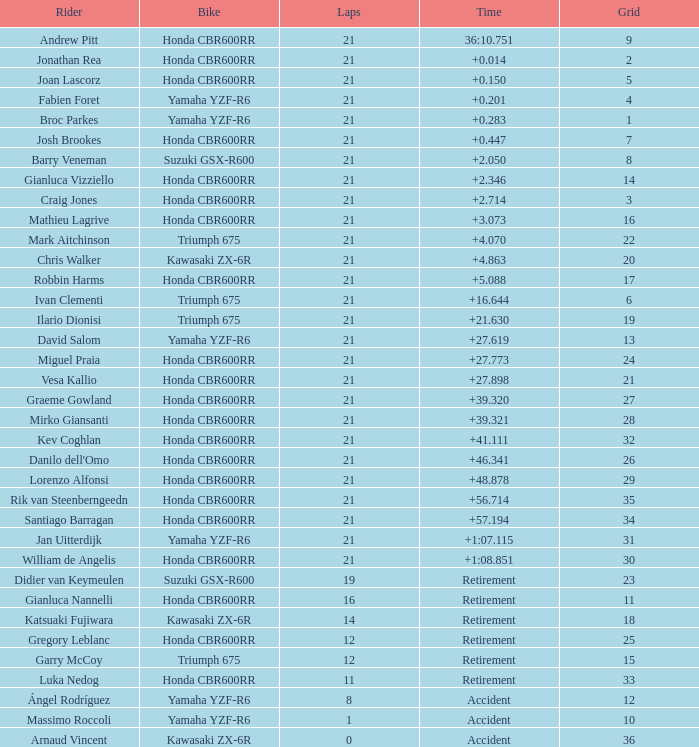Which driver completed fewer than 16 laps, began from the 10th spot on the grid, used a yamaha yzf-r6 motorcycle, and experienced a crash? Massimo Roccoli. 